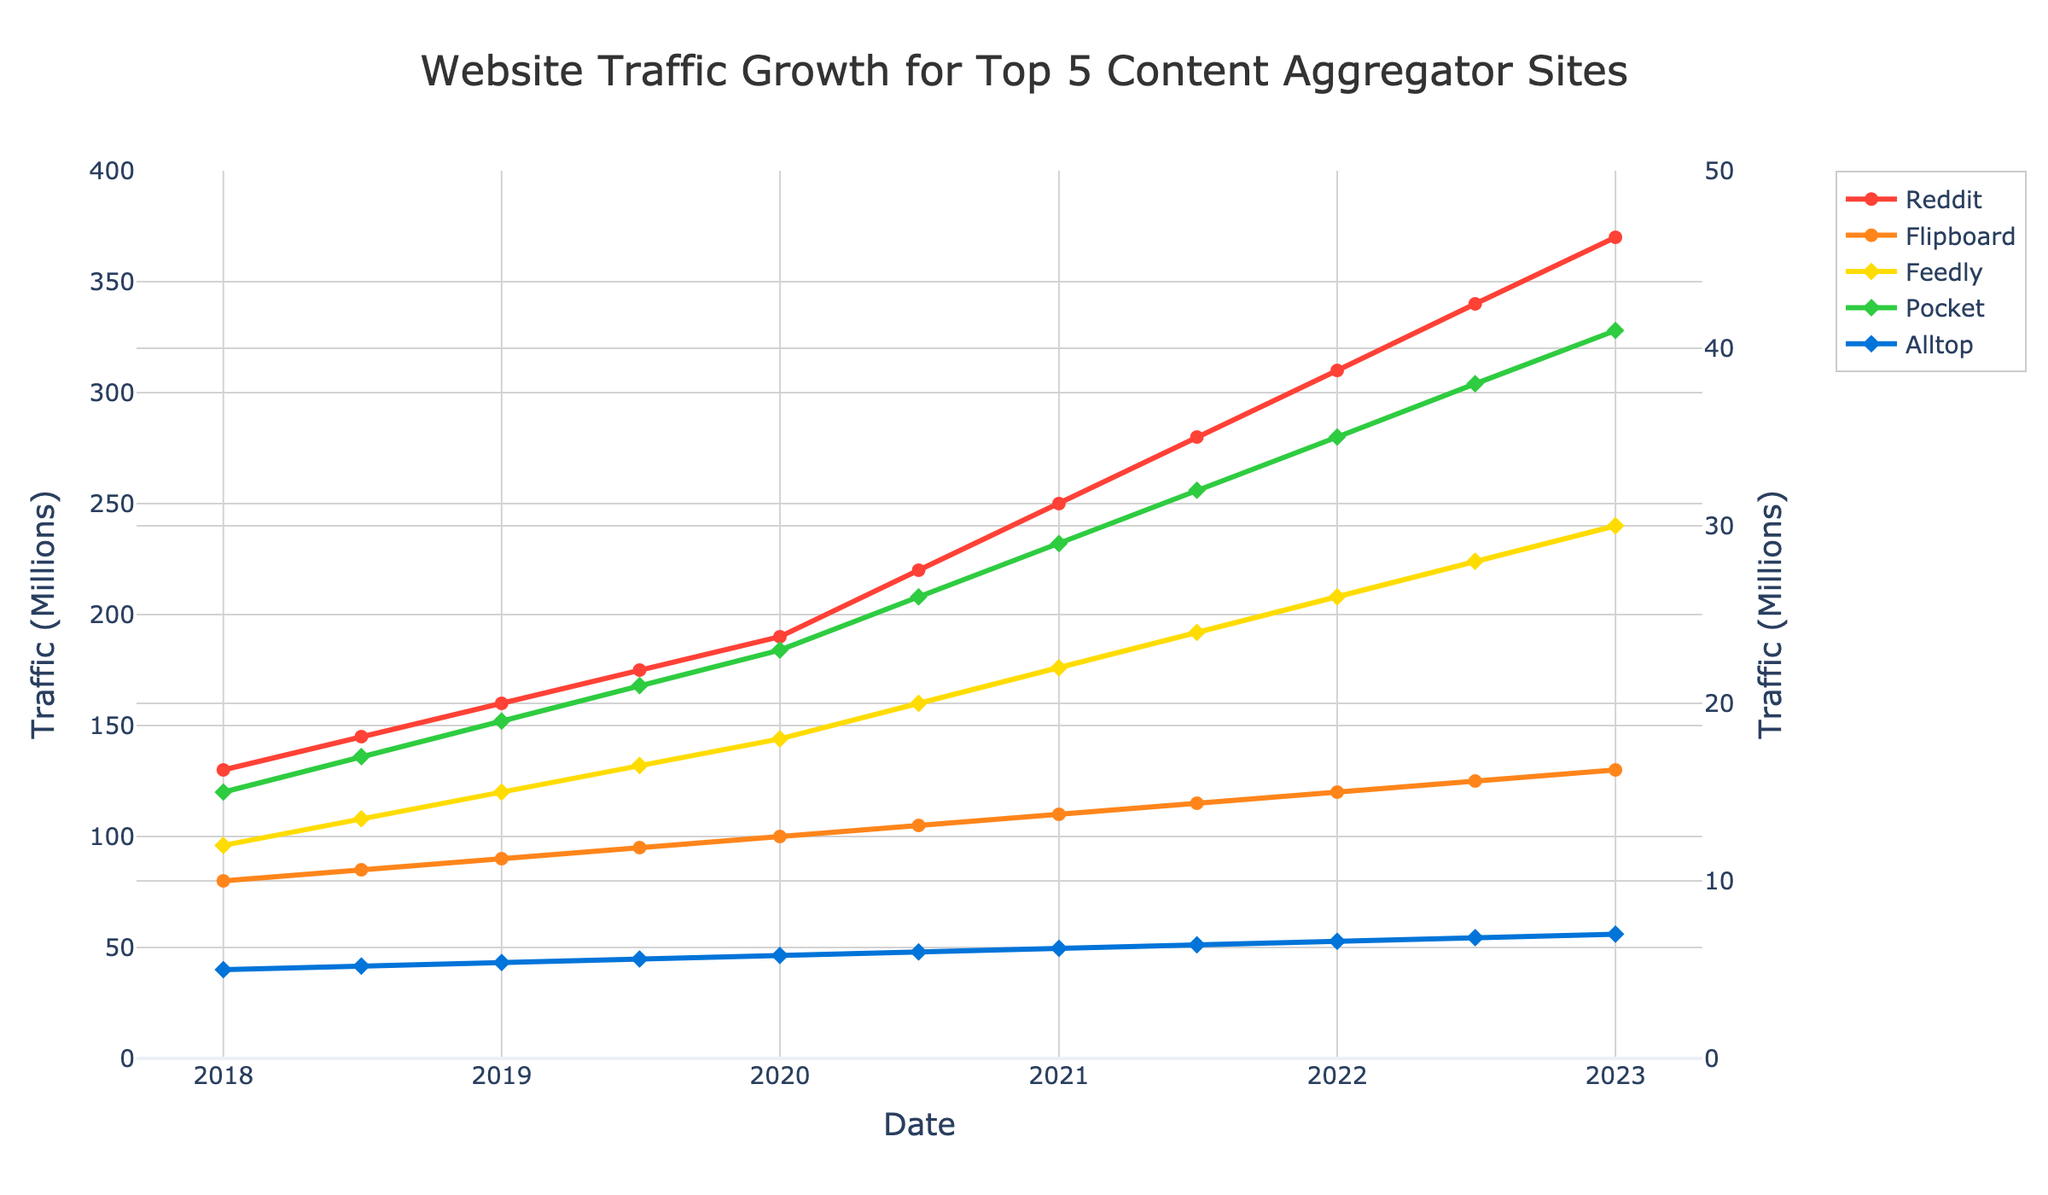Which site had the highest traffic in January 2023? Look at the y-axis values for January 2023 and check the corresponding points on the traffic lines. The site with the highest value is Reddit.
Answer: Reddit Which sites show consistent growth over the years? Observe the trend of each line from the start to the end. All lines (Reddit, Flipboard, Feedly, Pocket, and Alltop) show consistent upward growth.
Answer: Reddit, Flipboard, Feedly, Pocket, Alltop How much did Reddit's traffic increase from January 2018 to January 2023? Subtract the January 2018 traffic value of Reddit from its January 2023 value: 370,000,000 - 130,000,000 = 240,000,000.
Answer: 240,000,000 What's the average traffic for Pocket over the entire period? Sum all traffic values of Pocket and divide by the number of data points: (15000000 + 17000000 + 19000000 + 21000000 + 23000000 + 26000000 + 29000000 + 32000000 + 35000000 + 38000000 + 41000000) / 11.
Answer: 2,718,181.82 Which site had a larger increase in traffic from July 2020 to January 2021, Flipboard or Feedly? Calculate the traffic increase for both: 
Flipboard: 110,000,000 - 105,000,000 = 5,000,000 
Feedly: 22,000,000 - 20,000,000 = 2,000,000 
Flipboard had the larger increase.
Answer: Flipboard By how many millions did Alltop's traffic increase in total from July 2018 to July 2022? Calculate the difference in traffic between July 2022 and July 2018 for Alltop: (6,800,000 - 5,200,000) = 1,600,000. Convert to millions: 1,600,000 / 1,000,000 = 1.6.
Answer: 1.6 In which period did Feedly see the largest traffic growth? Compare the increase in traffic values between consecutive periods and find the maximum. The largest increase for Feedly is between July 2022 (28,000,000) and January 2023 (30,000,000), which is 2,000,000.
Answer: July 2022 to January 2023 Is there any site whose traffic surpassed 100 million before July 2020? Check the traffic values for dates before July 2020. Reddit's traffic surpassed 100 million before July 2020.
Answer: Reddit By how many millions did Pocket's traffic increase on average per half-year over the entire period? Calculate total increase: 41,000,000 - 15,000,000 = 26,000,000. Calculate the number of half-year periods: 11 - 1 = 10. Average increase per half-year: 26,000,000 / 10 = 2,600,000.
Answer: 2.6 